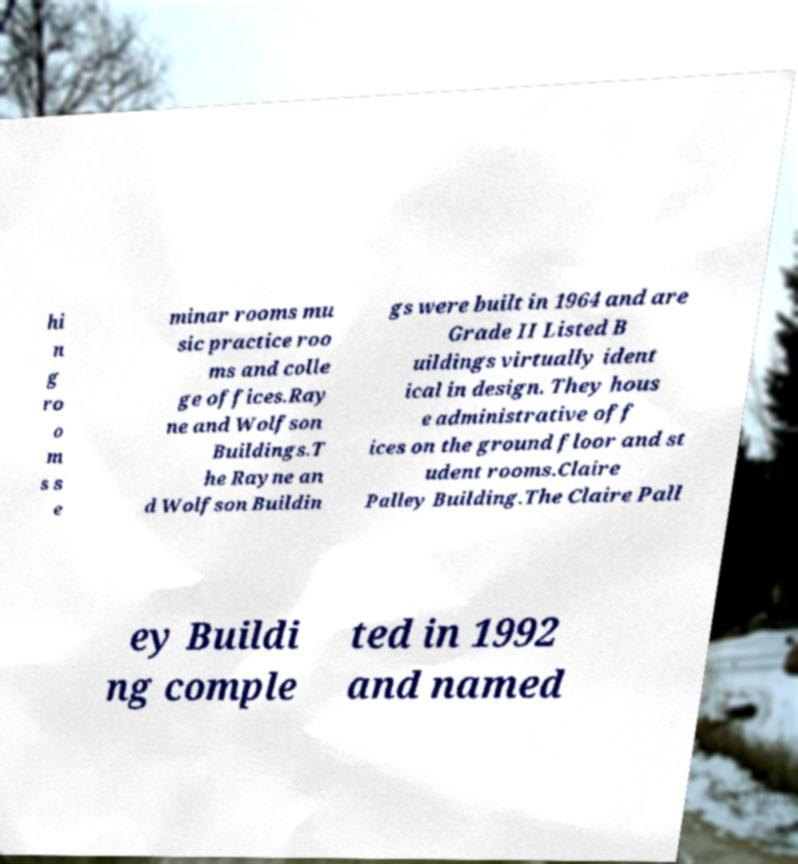What messages or text are displayed in this image? I need them in a readable, typed format. hi n g ro o m s s e minar rooms mu sic practice roo ms and colle ge offices.Ray ne and Wolfson Buildings.T he Rayne an d Wolfson Buildin gs were built in 1964 and are Grade II Listed B uildings virtually ident ical in design. They hous e administrative off ices on the ground floor and st udent rooms.Claire Palley Building.The Claire Pall ey Buildi ng comple ted in 1992 and named 